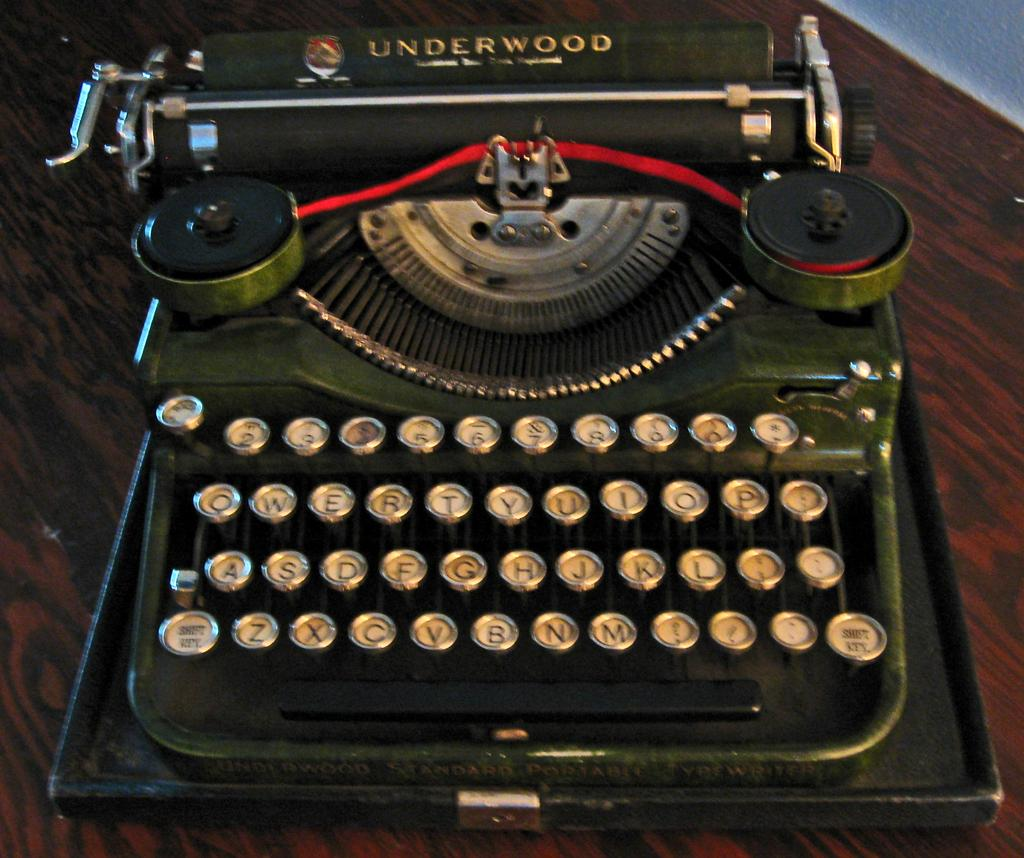<image>
Share a concise interpretation of the image provided. On a dark, wood surface is an old, green, Underwood type writer. 